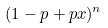<formula> <loc_0><loc_0><loc_500><loc_500>( 1 - p + p x ) ^ { n }</formula> 